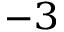Convert formula to latex. <formula><loc_0><loc_0><loc_500><loc_500>^ { - 3 }</formula> 